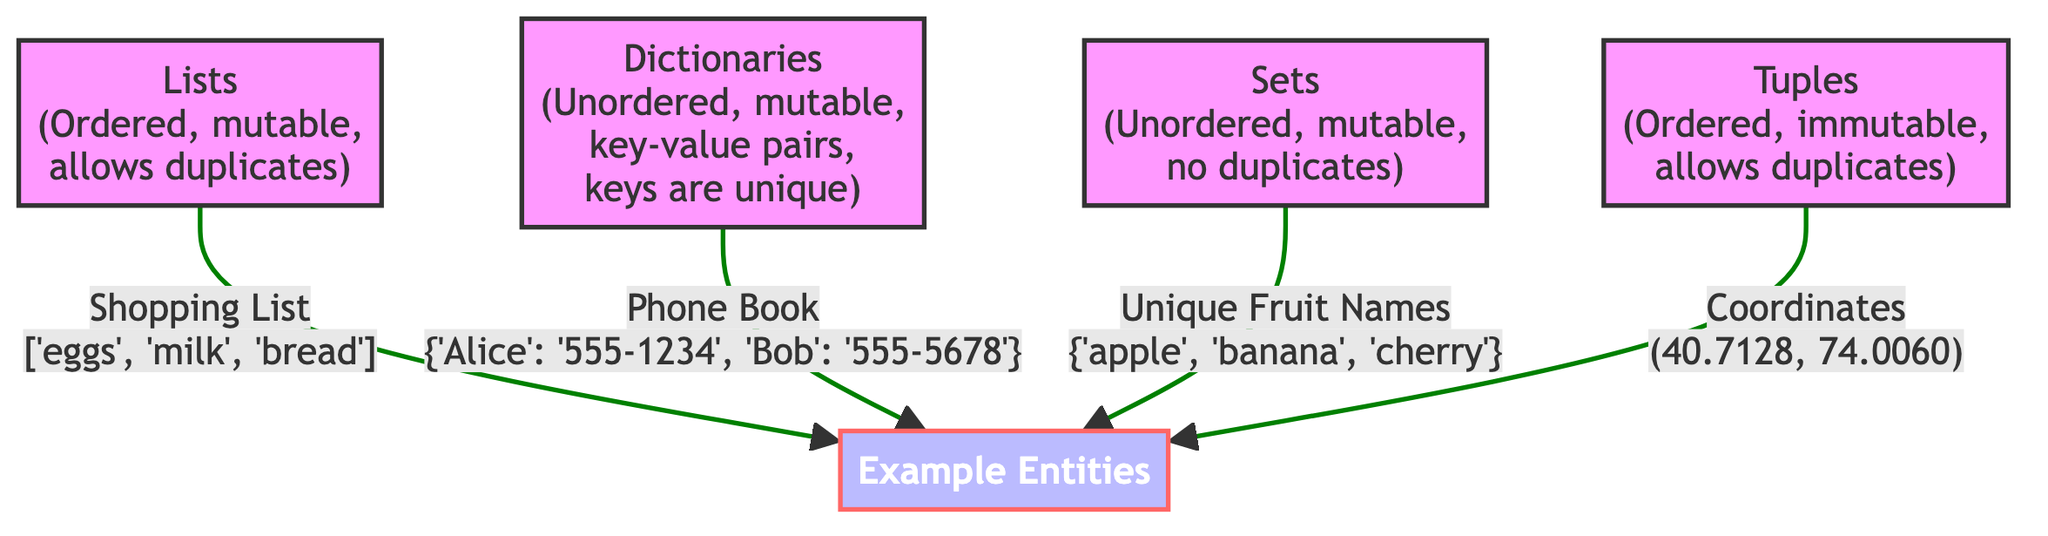What are the characteristics of sets? According to the diagram, sets are described as unordered, mutable, and they do not allow duplicates.
Answer: Unordered, mutable, no duplicates How many data structures are compared in this diagram? The diagram features four data structures: lists, dictionaries, sets, and tuples.
Answer: Four What is an example of a list given in the diagram? The diagram provides the example of a shopping list, which is represented as ['eggs', 'milk', 'bread'].
Answer: ['eggs', 'milk', 'bread'] What is unique about the keys in dictionaries? The diagram states that keys in dictionaries are unique, meaning that no two keys can have the same value.
Answer: Keys are unique What type of data structure is represented by coordinates (40.7128, 74.0060)? The diagram identifies coordinates as an example of a tuple, which is an ordered and immutable data structure.
Answer: Tuple What is the relationship between lists and their ability to allow duplicates? The diagram shows that lists allow duplicates, meaning that the same element can appear more than once in a list.
Answer: Allow duplicates Which data structure is characterized as immutable? The diagram indicates that tuples are characterized as immutable, meaning their content cannot change after creation.
Answer: Tuples Which data structure can contain key-value pairs? According to the diagram, dictionaries are the structure that contains key-value pairs.
Answer: Dictionaries What is the example entity for sets in the diagram? The diagram gives the example of unique fruit names, represented as {'apple', 'banana', 'cherry'}.
Answer: {'apple', 'banana', 'cherry'} 